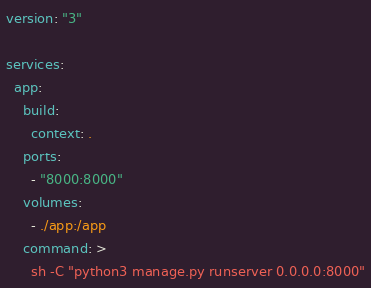Convert code to text. <code><loc_0><loc_0><loc_500><loc_500><_YAML_>version: "3"

services:
  app:
    build:
      context: .
    ports:
      - "8000:8000"
    volumes:
      - ./app:/app
    command: >
      sh -C "python3 manage.py runserver 0.0.0.0:8000"

</code> 